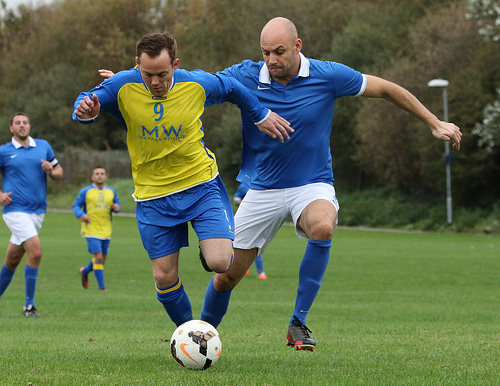<image>
Can you confirm if the shirt is on the man? No. The shirt is not positioned on the man. They may be near each other, but the shirt is not supported by or resting on top of the man. Where is the street light in relation to the football? Is it behind the football? Yes. From this viewpoint, the street light is positioned behind the football, with the football partially or fully occluding the street light. Where is the man in relation to the ball? Is it in front of the ball? No. The man is not in front of the ball. The spatial positioning shows a different relationship between these objects. 